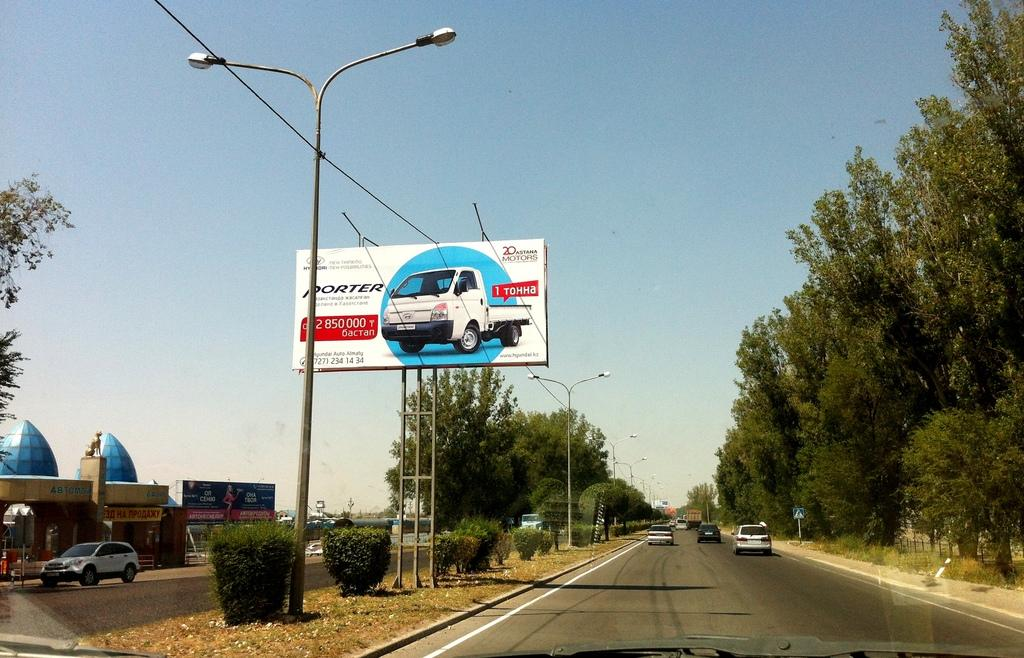What can be seen on the road in the image? There are vehicles on the road in the image. What type of natural elements are visible in the image? Trees are visible in the image. What structures are present in the image? Poles, sign boards, banners, and buildings are visible in the image. What is visible in the background of the image? The sky is visible in the background of the image. Can you tell me how many vests are hanging on the poles in the image? There is no mention of vests in the image; poles are present, but no vests are visible. What type of basket is being used to carry the banners in the image? There is no basket present in the image; banners are visible, but they are not being carried in a basket. 